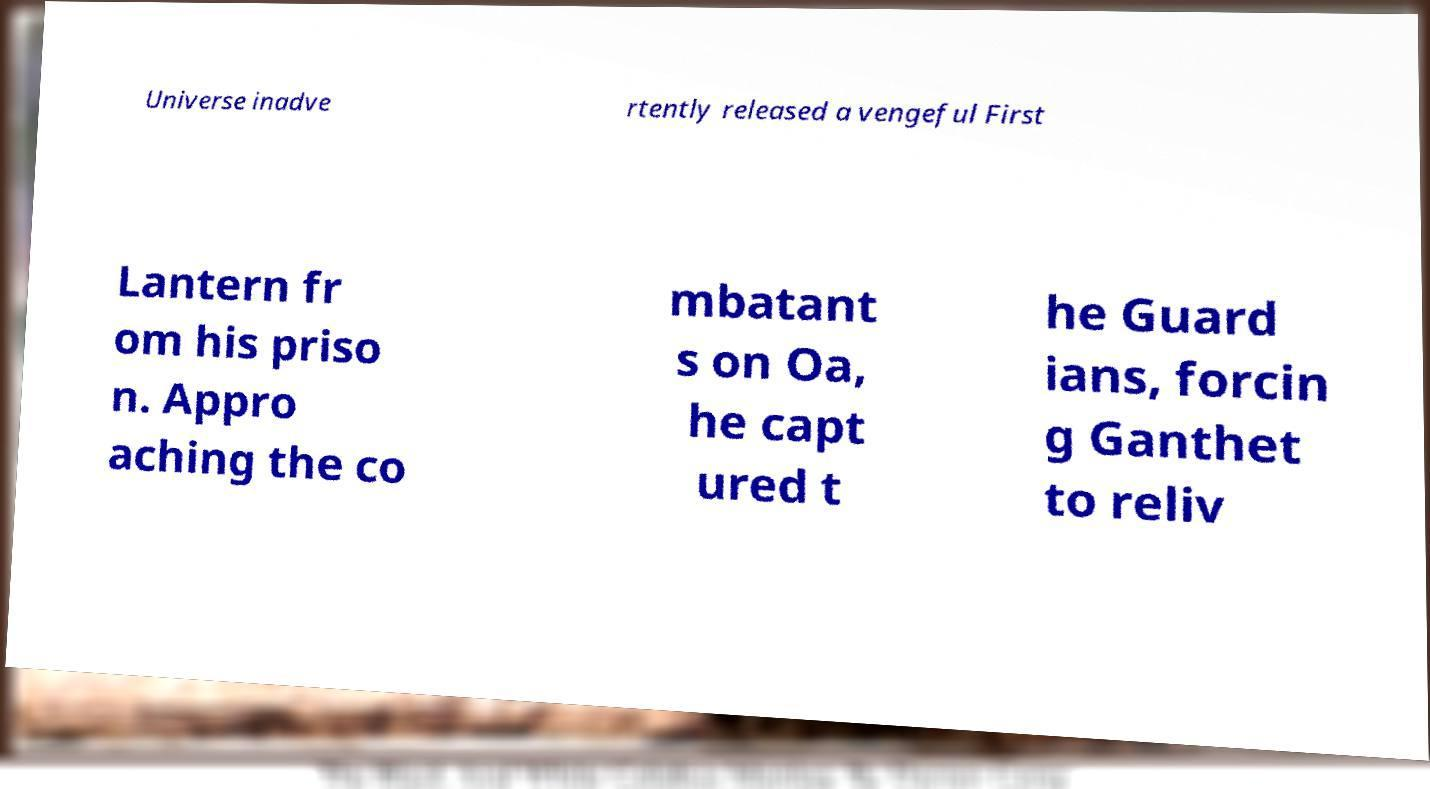Could you extract and type out the text from this image? Universe inadve rtently released a vengeful First Lantern fr om his priso n. Appro aching the co mbatant s on Oa, he capt ured t he Guard ians, forcin g Ganthet to reliv 